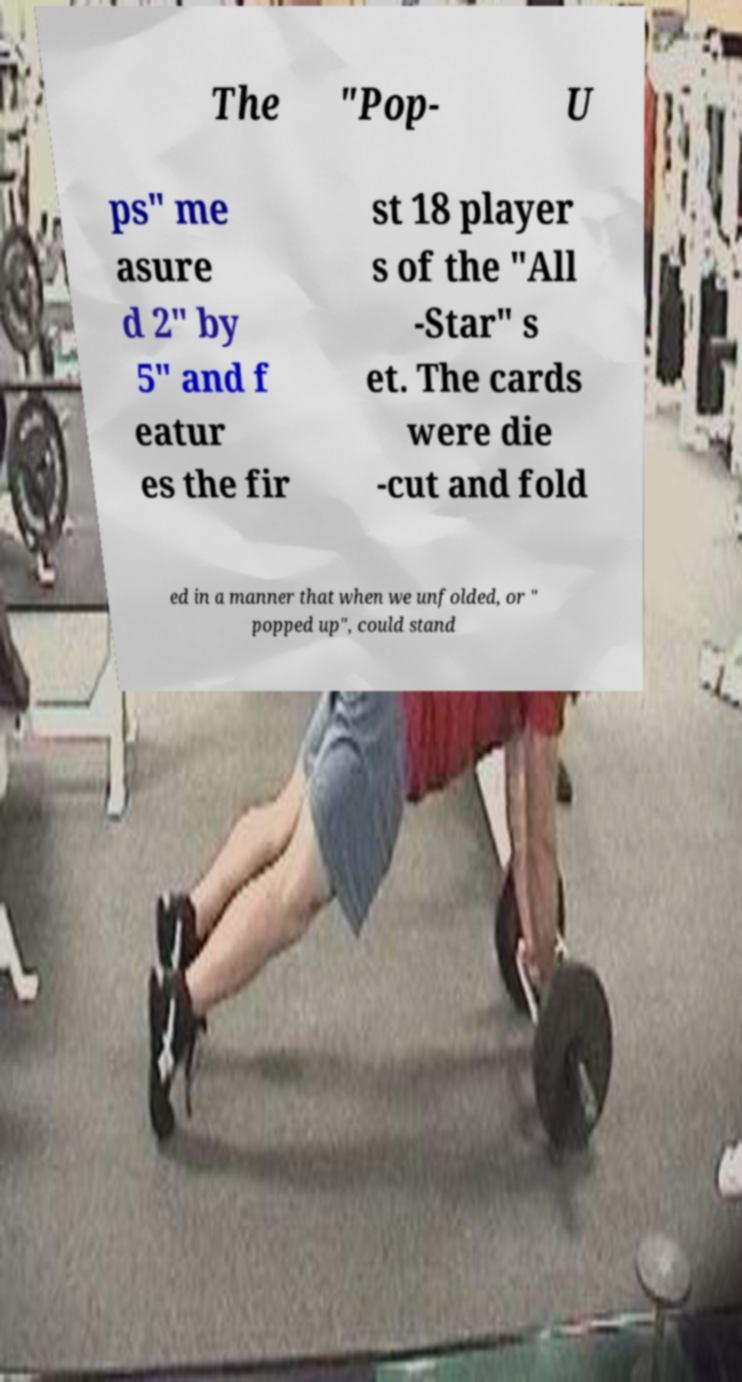Could you assist in decoding the text presented in this image and type it out clearly? The "Pop- U ps" me asure d 2" by 5" and f eatur es the fir st 18 player s of the "All -Star" s et. The cards were die -cut and fold ed in a manner that when we unfolded, or " popped up", could stand 